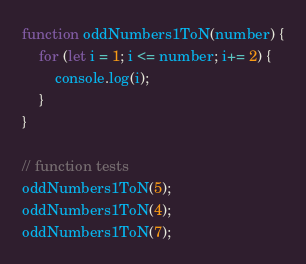<code> <loc_0><loc_0><loc_500><loc_500><_JavaScript_>function oddNumbers1ToN(number) {
    for (let i = 1; i <= number; i+= 2) {
        console.log(i);
    }
}

// function tests
oddNumbers1ToN(5);
oddNumbers1ToN(4);
oddNumbers1ToN(7);</code> 